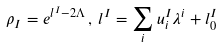Convert formula to latex. <formula><loc_0><loc_0><loc_500><loc_500>\rho _ { I } = e ^ { l ^ { I } - 2 \Lambda } \, , \, l ^ { I } = \sum _ { i } u ^ { I } _ { i } \lambda ^ { i } + l ^ { I } _ { 0 }</formula> 